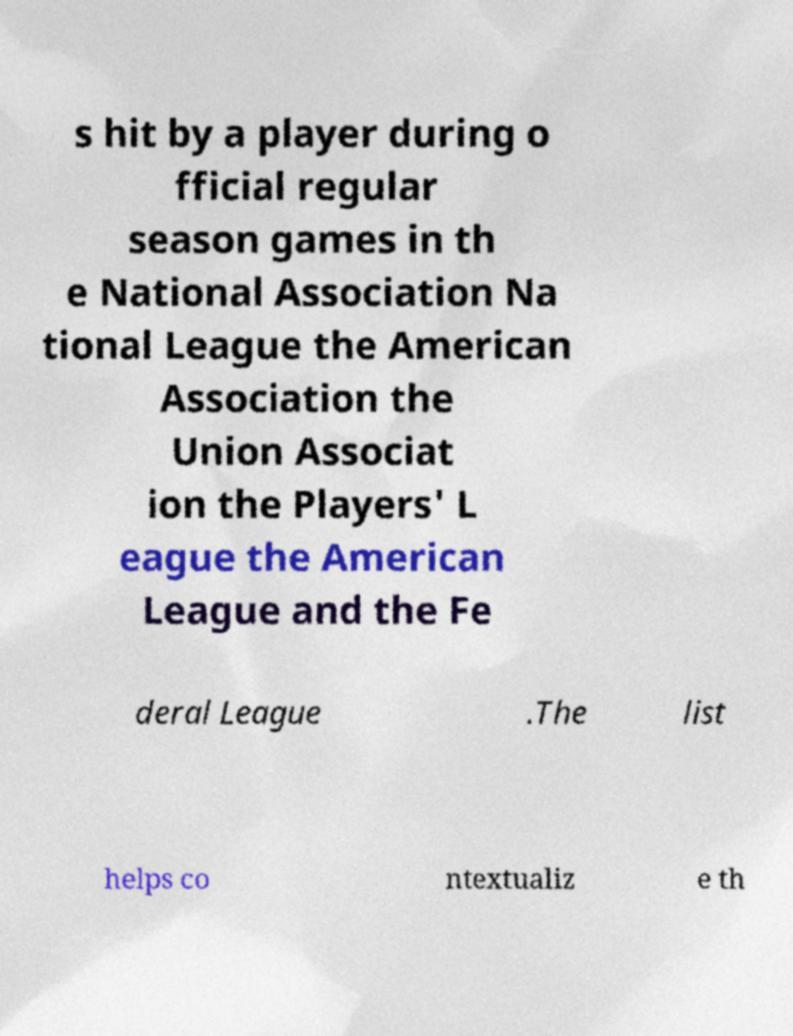For documentation purposes, I need the text within this image transcribed. Could you provide that? s hit by a player during o fficial regular season games in th e National Association Na tional League the American Association the Union Associat ion the Players' L eague the American League and the Fe deral League .The list helps co ntextualiz e th 